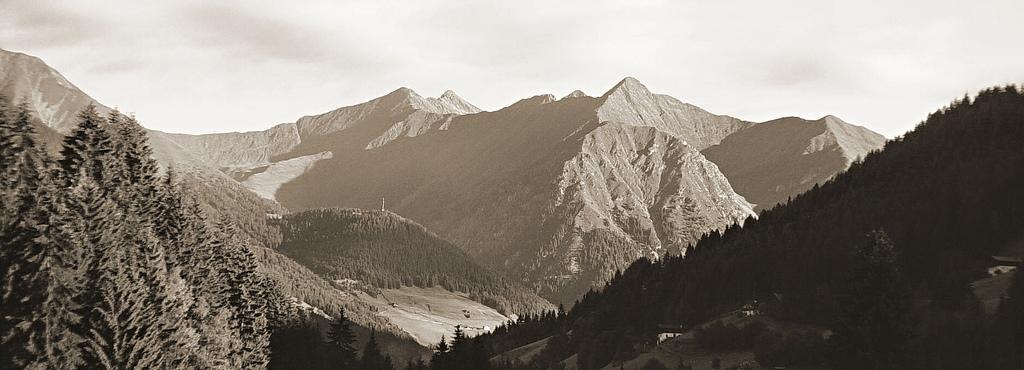Can you describe this image briefly? In this image I can see many trees. In the background I can see the mountains and the sky. 